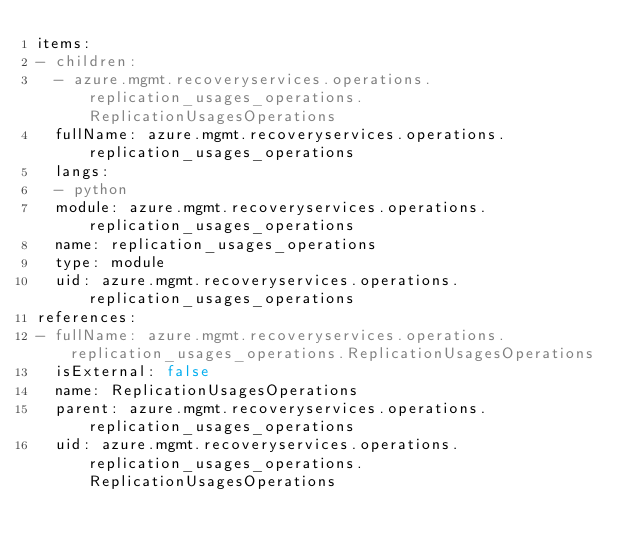Convert code to text. <code><loc_0><loc_0><loc_500><loc_500><_YAML_>items:
- children:
  - azure.mgmt.recoveryservices.operations.replication_usages_operations.ReplicationUsagesOperations
  fullName: azure.mgmt.recoveryservices.operations.replication_usages_operations
  langs:
  - python
  module: azure.mgmt.recoveryservices.operations.replication_usages_operations
  name: replication_usages_operations
  type: module
  uid: azure.mgmt.recoveryservices.operations.replication_usages_operations
references:
- fullName: azure.mgmt.recoveryservices.operations.replication_usages_operations.ReplicationUsagesOperations
  isExternal: false
  name: ReplicationUsagesOperations
  parent: azure.mgmt.recoveryservices.operations.replication_usages_operations
  uid: azure.mgmt.recoveryservices.operations.replication_usages_operations.ReplicationUsagesOperations
</code> 